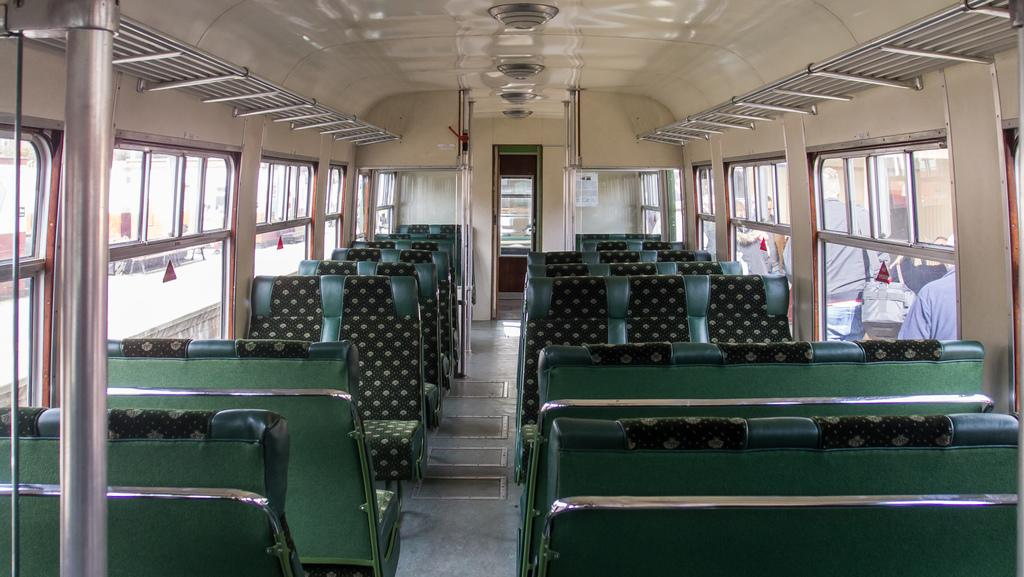What type of vehicle is shown in the image? The image is an inside view of a bus. What are some of the features of the bus? There are rods, seats, windows, a poster, and lights in the bus. Can you see outside the bus through the windows? Yes, people and objects are visible through the glass. What type of art can be seen hanging on the walls of the bus? There is no art visible on the walls of the bus in the image. How many cows are present in the bus? There are no cows present in the bus; the image only shows the interior of the vehicle. 